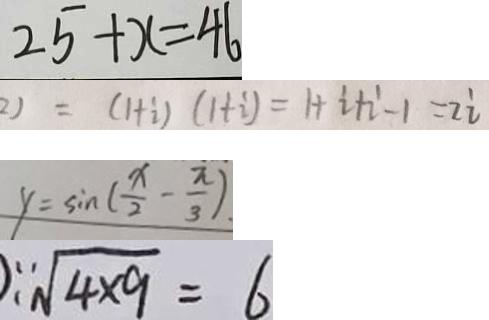<formula> <loc_0><loc_0><loc_500><loc_500>2 5 + x = 4 6 
 2 ) = ( 1 + i ) ( 1 + i ) = 1 + i + i - 1 = 2 i 
 y = \sin ( \frac { x } { 2 } - \frac { \pi } { 3 } ) 
 \sqrt [ 3 ] { 4 \times 9 } = 6</formula> 